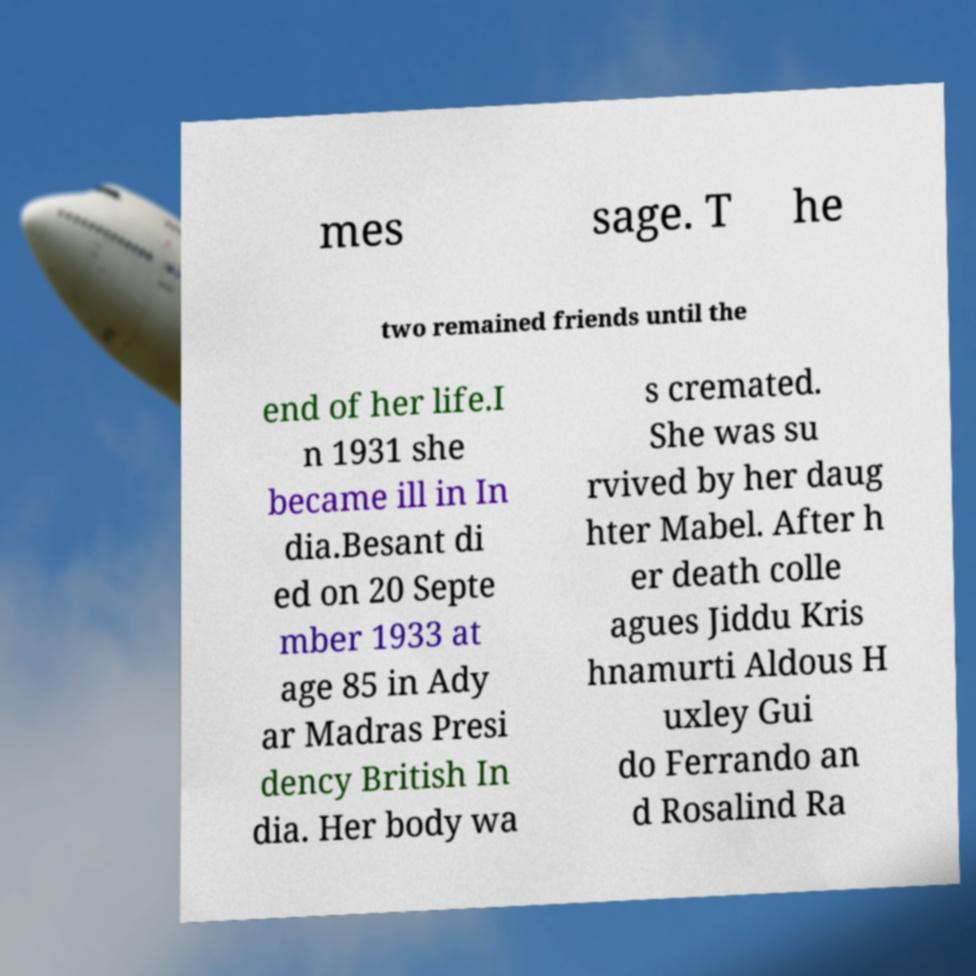For documentation purposes, I need the text within this image transcribed. Could you provide that? mes sage. T he two remained friends until the end of her life.I n 1931 she became ill in In dia.Besant di ed on 20 Septe mber 1933 at age 85 in Ady ar Madras Presi dency British In dia. Her body wa s cremated. She was su rvived by her daug hter Mabel. After h er death colle agues Jiddu Kris hnamurti Aldous H uxley Gui do Ferrando an d Rosalind Ra 